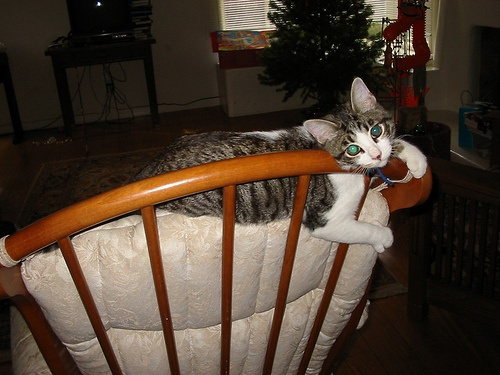Describe the objects in this image and their specific colors. I can see chair in black, darkgray, maroon, and gray tones, cat in black, gray, maroon, and darkgray tones, potted plant in black, gray, and darkgreen tones, and tv in black, white, navy, and gray tones in this image. 